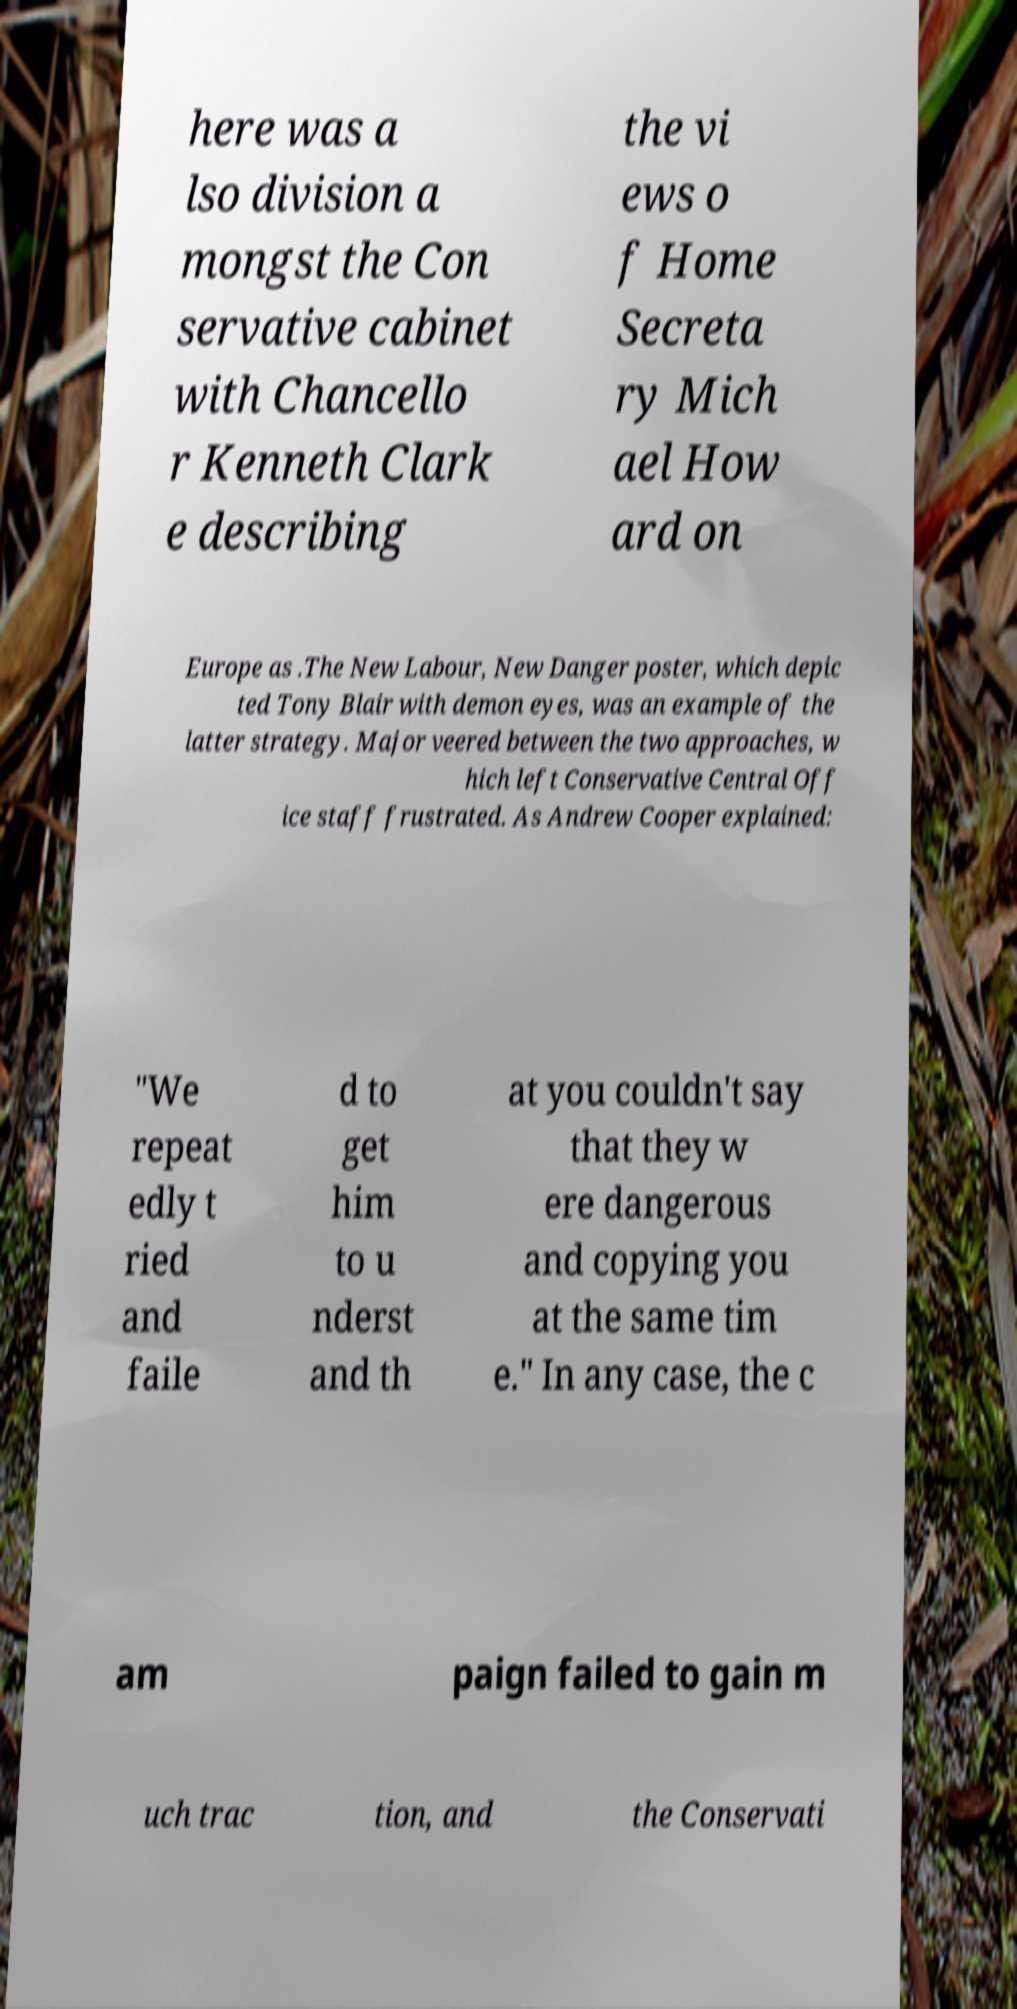There's text embedded in this image that I need extracted. Can you transcribe it verbatim? here was a lso division a mongst the Con servative cabinet with Chancello r Kenneth Clark e describing the vi ews o f Home Secreta ry Mich ael How ard on Europe as .The New Labour, New Danger poster, which depic ted Tony Blair with demon eyes, was an example of the latter strategy. Major veered between the two approaches, w hich left Conservative Central Off ice staff frustrated. As Andrew Cooper explained: "We repeat edly t ried and faile d to get him to u nderst and th at you couldn't say that they w ere dangerous and copying you at the same tim e." In any case, the c am paign failed to gain m uch trac tion, and the Conservati 